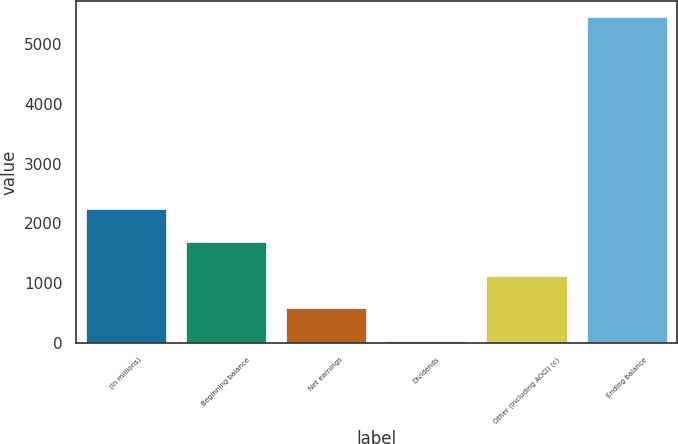Convert chart. <chart><loc_0><loc_0><loc_500><loc_500><bar_chart><fcel>(In millions)<fcel>Beginning balance<fcel>Net earnings<fcel>Dividends<fcel>Other (including AOCI) (c)<fcel>Ending balance<nl><fcel>2236.2<fcel>1696<fcel>582.2<fcel>42<fcel>1122.4<fcel>5444<nl></chart> 